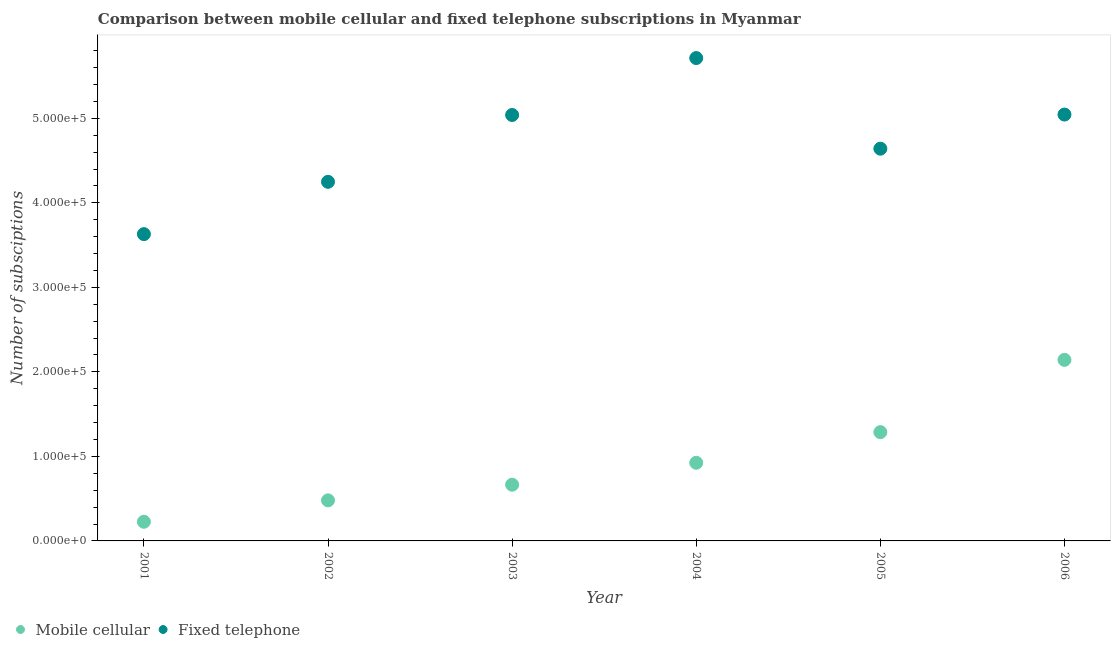What is the number of fixed telephone subscriptions in 2002?
Your answer should be very brief. 4.25e+05. Across all years, what is the maximum number of mobile cellular subscriptions?
Ensure brevity in your answer.  2.14e+05. Across all years, what is the minimum number of mobile cellular subscriptions?
Your answer should be very brief. 2.27e+04. What is the total number of mobile cellular subscriptions in the graph?
Provide a short and direct response. 5.73e+05. What is the difference between the number of fixed telephone subscriptions in 2002 and that in 2003?
Keep it short and to the point. -7.91e+04. What is the difference between the number of mobile cellular subscriptions in 2002 and the number of fixed telephone subscriptions in 2005?
Your response must be concise. -4.16e+05. What is the average number of mobile cellular subscriptions per year?
Give a very brief answer. 9.54e+04. In the year 2005, what is the difference between the number of fixed telephone subscriptions and number of mobile cellular subscriptions?
Offer a very short reply. 3.35e+05. What is the ratio of the number of fixed telephone subscriptions in 2004 to that in 2005?
Provide a short and direct response. 1.23. Is the number of fixed telephone subscriptions in 2002 less than that in 2006?
Provide a short and direct response. Yes. Is the difference between the number of mobile cellular subscriptions in 2002 and 2005 greater than the difference between the number of fixed telephone subscriptions in 2002 and 2005?
Your answer should be very brief. No. What is the difference between the highest and the second highest number of fixed telephone subscriptions?
Give a very brief answer. 6.68e+04. What is the difference between the highest and the lowest number of mobile cellular subscriptions?
Provide a succinct answer. 1.92e+05. In how many years, is the number of mobile cellular subscriptions greater than the average number of mobile cellular subscriptions taken over all years?
Make the answer very short. 2. Is the number of mobile cellular subscriptions strictly greater than the number of fixed telephone subscriptions over the years?
Offer a terse response. No. What is the difference between two consecutive major ticks on the Y-axis?
Make the answer very short. 1.00e+05. Are the values on the major ticks of Y-axis written in scientific E-notation?
Give a very brief answer. Yes. Does the graph contain any zero values?
Your answer should be compact. No. What is the title of the graph?
Provide a succinct answer. Comparison between mobile cellular and fixed telephone subscriptions in Myanmar. What is the label or title of the X-axis?
Offer a very short reply. Year. What is the label or title of the Y-axis?
Your answer should be compact. Number of subsciptions. What is the Number of subsciptions in Mobile cellular in 2001?
Give a very brief answer. 2.27e+04. What is the Number of subsciptions of Fixed telephone in 2001?
Offer a very short reply. 3.63e+05. What is the Number of subsciptions in Mobile cellular in 2002?
Your answer should be compact. 4.80e+04. What is the Number of subsciptions of Fixed telephone in 2002?
Make the answer very short. 4.25e+05. What is the Number of subsciptions of Mobile cellular in 2003?
Your answer should be very brief. 6.65e+04. What is the Number of subsciptions in Fixed telephone in 2003?
Keep it short and to the point. 5.04e+05. What is the Number of subsciptions in Mobile cellular in 2004?
Provide a short and direct response. 9.25e+04. What is the Number of subsciptions of Fixed telephone in 2004?
Give a very brief answer. 5.71e+05. What is the Number of subsciptions in Mobile cellular in 2005?
Ensure brevity in your answer.  1.29e+05. What is the Number of subsciptions of Fixed telephone in 2005?
Offer a very short reply. 4.64e+05. What is the Number of subsciptions in Mobile cellular in 2006?
Make the answer very short. 2.14e+05. What is the Number of subsciptions in Fixed telephone in 2006?
Provide a short and direct response. 5.04e+05. Across all years, what is the maximum Number of subsciptions of Mobile cellular?
Provide a short and direct response. 2.14e+05. Across all years, what is the maximum Number of subsciptions in Fixed telephone?
Your answer should be compact. 5.71e+05. Across all years, what is the minimum Number of subsciptions of Mobile cellular?
Provide a short and direct response. 2.27e+04. Across all years, what is the minimum Number of subsciptions in Fixed telephone?
Your response must be concise. 3.63e+05. What is the total Number of subsciptions in Mobile cellular in the graph?
Offer a terse response. 5.73e+05. What is the total Number of subsciptions in Fixed telephone in the graph?
Give a very brief answer. 2.83e+06. What is the difference between the Number of subsciptions in Mobile cellular in 2001 and that in 2002?
Offer a terse response. -2.53e+04. What is the difference between the Number of subsciptions of Fixed telephone in 2001 and that in 2002?
Provide a succinct answer. -6.19e+04. What is the difference between the Number of subsciptions of Mobile cellular in 2001 and that in 2003?
Offer a very short reply. -4.38e+04. What is the difference between the Number of subsciptions of Fixed telephone in 2001 and that in 2003?
Your response must be concise. -1.41e+05. What is the difference between the Number of subsciptions in Mobile cellular in 2001 and that in 2004?
Offer a terse response. -6.98e+04. What is the difference between the Number of subsciptions of Fixed telephone in 2001 and that in 2004?
Provide a short and direct response. -2.08e+05. What is the difference between the Number of subsciptions of Mobile cellular in 2001 and that in 2005?
Keep it short and to the point. -1.06e+05. What is the difference between the Number of subsciptions of Fixed telephone in 2001 and that in 2005?
Provide a short and direct response. -1.01e+05. What is the difference between the Number of subsciptions of Mobile cellular in 2001 and that in 2006?
Provide a succinct answer. -1.92e+05. What is the difference between the Number of subsciptions in Fixed telephone in 2001 and that in 2006?
Offer a terse response. -1.41e+05. What is the difference between the Number of subsciptions in Mobile cellular in 2002 and that in 2003?
Your answer should be very brief. -1.85e+04. What is the difference between the Number of subsciptions of Fixed telephone in 2002 and that in 2003?
Your answer should be very brief. -7.91e+04. What is the difference between the Number of subsciptions of Mobile cellular in 2002 and that in 2004?
Your answer should be compact. -4.45e+04. What is the difference between the Number of subsciptions of Fixed telephone in 2002 and that in 2004?
Ensure brevity in your answer.  -1.46e+05. What is the difference between the Number of subsciptions in Mobile cellular in 2002 and that in 2005?
Offer a terse response. -8.07e+04. What is the difference between the Number of subsciptions of Fixed telephone in 2002 and that in 2005?
Make the answer very short. -3.92e+04. What is the difference between the Number of subsciptions of Mobile cellular in 2002 and that in 2006?
Ensure brevity in your answer.  -1.66e+05. What is the difference between the Number of subsciptions of Fixed telephone in 2002 and that in 2006?
Your answer should be very brief. -7.96e+04. What is the difference between the Number of subsciptions in Mobile cellular in 2003 and that in 2004?
Your answer should be very brief. -2.59e+04. What is the difference between the Number of subsciptions of Fixed telephone in 2003 and that in 2004?
Your response must be concise. -6.74e+04. What is the difference between the Number of subsciptions of Mobile cellular in 2003 and that in 2005?
Make the answer very short. -6.22e+04. What is the difference between the Number of subsciptions of Fixed telephone in 2003 and that in 2005?
Your answer should be compact. 3.98e+04. What is the difference between the Number of subsciptions of Mobile cellular in 2003 and that in 2006?
Provide a succinct answer. -1.48e+05. What is the difference between the Number of subsciptions of Fixed telephone in 2003 and that in 2006?
Provide a succinct answer. -515. What is the difference between the Number of subsciptions in Mobile cellular in 2004 and that in 2005?
Keep it short and to the point. -3.62e+04. What is the difference between the Number of subsciptions in Fixed telephone in 2004 and that in 2005?
Offer a very short reply. 1.07e+05. What is the difference between the Number of subsciptions of Mobile cellular in 2004 and that in 2006?
Your answer should be compact. -1.22e+05. What is the difference between the Number of subsciptions in Fixed telephone in 2004 and that in 2006?
Your answer should be very brief. 6.68e+04. What is the difference between the Number of subsciptions of Mobile cellular in 2005 and that in 2006?
Provide a short and direct response. -8.55e+04. What is the difference between the Number of subsciptions in Fixed telephone in 2005 and that in 2006?
Make the answer very short. -4.04e+04. What is the difference between the Number of subsciptions of Mobile cellular in 2001 and the Number of subsciptions of Fixed telephone in 2002?
Give a very brief answer. -4.02e+05. What is the difference between the Number of subsciptions of Mobile cellular in 2001 and the Number of subsciptions of Fixed telephone in 2003?
Your response must be concise. -4.81e+05. What is the difference between the Number of subsciptions in Mobile cellular in 2001 and the Number of subsciptions in Fixed telephone in 2004?
Provide a succinct answer. -5.49e+05. What is the difference between the Number of subsciptions of Mobile cellular in 2001 and the Number of subsciptions of Fixed telephone in 2005?
Offer a very short reply. -4.41e+05. What is the difference between the Number of subsciptions of Mobile cellular in 2001 and the Number of subsciptions of Fixed telephone in 2006?
Ensure brevity in your answer.  -4.82e+05. What is the difference between the Number of subsciptions of Mobile cellular in 2002 and the Number of subsciptions of Fixed telephone in 2003?
Provide a short and direct response. -4.56e+05. What is the difference between the Number of subsciptions in Mobile cellular in 2002 and the Number of subsciptions in Fixed telephone in 2004?
Provide a succinct answer. -5.23e+05. What is the difference between the Number of subsciptions in Mobile cellular in 2002 and the Number of subsciptions in Fixed telephone in 2005?
Keep it short and to the point. -4.16e+05. What is the difference between the Number of subsciptions of Mobile cellular in 2002 and the Number of subsciptions of Fixed telephone in 2006?
Offer a very short reply. -4.56e+05. What is the difference between the Number of subsciptions of Mobile cellular in 2003 and the Number of subsciptions of Fixed telephone in 2004?
Ensure brevity in your answer.  -5.05e+05. What is the difference between the Number of subsciptions in Mobile cellular in 2003 and the Number of subsciptions in Fixed telephone in 2005?
Provide a short and direct response. -3.98e+05. What is the difference between the Number of subsciptions of Mobile cellular in 2003 and the Number of subsciptions of Fixed telephone in 2006?
Your response must be concise. -4.38e+05. What is the difference between the Number of subsciptions of Mobile cellular in 2004 and the Number of subsciptions of Fixed telephone in 2005?
Provide a succinct answer. -3.72e+05. What is the difference between the Number of subsciptions of Mobile cellular in 2004 and the Number of subsciptions of Fixed telephone in 2006?
Offer a terse response. -4.12e+05. What is the difference between the Number of subsciptions in Mobile cellular in 2005 and the Number of subsciptions in Fixed telephone in 2006?
Provide a succinct answer. -3.76e+05. What is the average Number of subsciptions of Mobile cellular per year?
Offer a very short reply. 9.54e+04. What is the average Number of subsciptions in Fixed telephone per year?
Your response must be concise. 4.72e+05. In the year 2001, what is the difference between the Number of subsciptions in Mobile cellular and Number of subsciptions in Fixed telephone?
Make the answer very short. -3.40e+05. In the year 2002, what is the difference between the Number of subsciptions of Mobile cellular and Number of subsciptions of Fixed telephone?
Make the answer very short. -3.77e+05. In the year 2003, what is the difference between the Number of subsciptions in Mobile cellular and Number of subsciptions in Fixed telephone?
Offer a terse response. -4.37e+05. In the year 2004, what is the difference between the Number of subsciptions in Mobile cellular and Number of subsciptions in Fixed telephone?
Provide a succinct answer. -4.79e+05. In the year 2005, what is the difference between the Number of subsciptions in Mobile cellular and Number of subsciptions in Fixed telephone?
Provide a short and direct response. -3.35e+05. In the year 2006, what is the difference between the Number of subsciptions in Mobile cellular and Number of subsciptions in Fixed telephone?
Provide a succinct answer. -2.90e+05. What is the ratio of the Number of subsciptions in Mobile cellular in 2001 to that in 2002?
Your response must be concise. 0.47. What is the ratio of the Number of subsciptions in Fixed telephone in 2001 to that in 2002?
Offer a very short reply. 0.85. What is the ratio of the Number of subsciptions of Mobile cellular in 2001 to that in 2003?
Ensure brevity in your answer.  0.34. What is the ratio of the Number of subsciptions of Fixed telephone in 2001 to that in 2003?
Your answer should be compact. 0.72. What is the ratio of the Number of subsciptions in Mobile cellular in 2001 to that in 2004?
Give a very brief answer. 0.25. What is the ratio of the Number of subsciptions of Fixed telephone in 2001 to that in 2004?
Keep it short and to the point. 0.64. What is the ratio of the Number of subsciptions in Mobile cellular in 2001 to that in 2005?
Provide a succinct answer. 0.18. What is the ratio of the Number of subsciptions of Fixed telephone in 2001 to that in 2005?
Give a very brief answer. 0.78. What is the ratio of the Number of subsciptions of Mobile cellular in 2001 to that in 2006?
Offer a terse response. 0.11. What is the ratio of the Number of subsciptions in Fixed telephone in 2001 to that in 2006?
Your answer should be very brief. 0.72. What is the ratio of the Number of subsciptions of Mobile cellular in 2002 to that in 2003?
Provide a succinct answer. 0.72. What is the ratio of the Number of subsciptions in Fixed telephone in 2002 to that in 2003?
Offer a very short reply. 0.84. What is the ratio of the Number of subsciptions of Mobile cellular in 2002 to that in 2004?
Ensure brevity in your answer.  0.52. What is the ratio of the Number of subsciptions of Fixed telephone in 2002 to that in 2004?
Offer a terse response. 0.74. What is the ratio of the Number of subsciptions of Mobile cellular in 2002 to that in 2005?
Your response must be concise. 0.37. What is the ratio of the Number of subsciptions of Fixed telephone in 2002 to that in 2005?
Provide a succinct answer. 0.92. What is the ratio of the Number of subsciptions of Mobile cellular in 2002 to that in 2006?
Your answer should be compact. 0.22. What is the ratio of the Number of subsciptions in Fixed telephone in 2002 to that in 2006?
Make the answer very short. 0.84. What is the ratio of the Number of subsciptions of Mobile cellular in 2003 to that in 2004?
Your answer should be compact. 0.72. What is the ratio of the Number of subsciptions in Fixed telephone in 2003 to that in 2004?
Your response must be concise. 0.88. What is the ratio of the Number of subsciptions in Mobile cellular in 2003 to that in 2005?
Your answer should be compact. 0.52. What is the ratio of the Number of subsciptions of Fixed telephone in 2003 to that in 2005?
Offer a terse response. 1.09. What is the ratio of the Number of subsciptions in Mobile cellular in 2003 to that in 2006?
Your answer should be very brief. 0.31. What is the ratio of the Number of subsciptions of Mobile cellular in 2004 to that in 2005?
Provide a short and direct response. 0.72. What is the ratio of the Number of subsciptions in Fixed telephone in 2004 to that in 2005?
Your response must be concise. 1.23. What is the ratio of the Number of subsciptions in Mobile cellular in 2004 to that in 2006?
Provide a short and direct response. 0.43. What is the ratio of the Number of subsciptions of Fixed telephone in 2004 to that in 2006?
Ensure brevity in your answer.  1.13. What is the ratio of the Number of subsciptions of Mobile cellular in 2005 to that in 2006?
Offer a terse response. 0.6. What is the difference between the highest and the second highest Number of subsciptions of Mobile cellular?
Your answer should be very brief. 8.55e+04. What is the difference between the highest and the second highest Number of subsciptions of Fixed telephone?
Keep it short and to the point. 6.68e+04. What is the difference between the highest and the lowest Number of subsciptions of Mobile cellular?
Give a very brief answer. 1.92e+05. What is the difference between the highest and the lowest Number of subsciptions in Fixed telephone?
Give a very brief answer. 2.08e+05. 